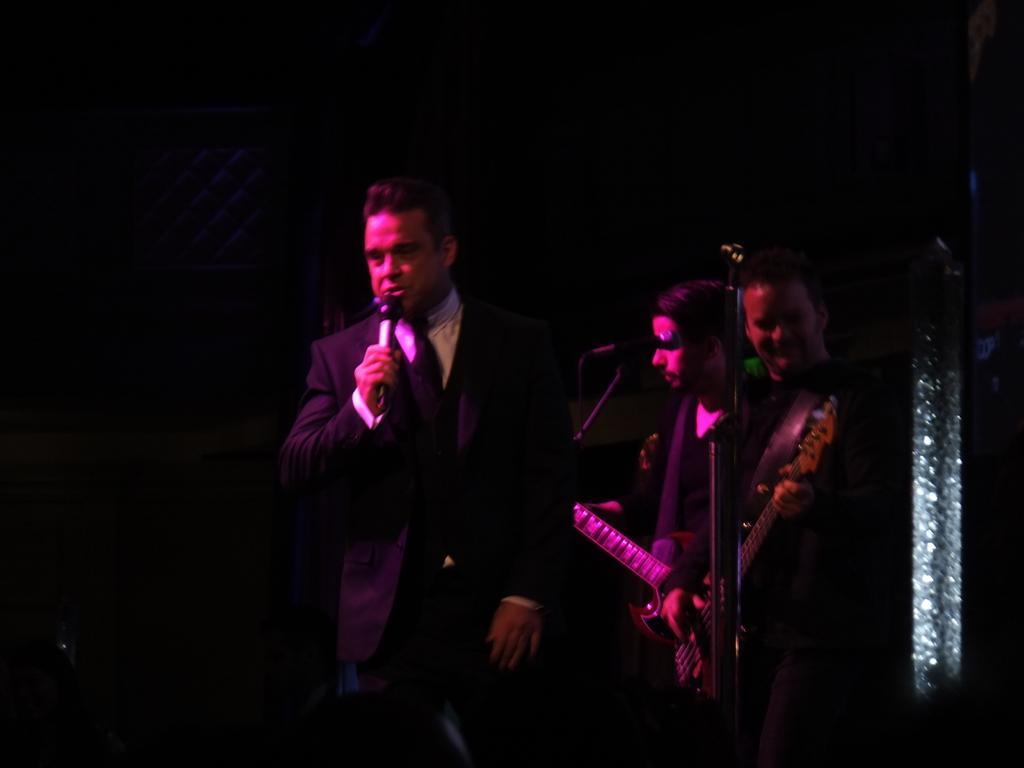Could you give a brief overview of what you see in this image? In this picture i could see three persons doing some stage performance holding some musical instruments in their hands. One of the person in the formal holding a mic. I could see a black background. 